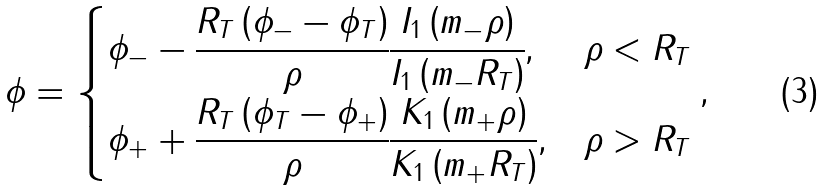Convert formula to latex. <formula><loc_0><loc_0><loc_500><loc_500>\phi = \begin{cases} \phi _ { - } - \cfrac { { R _ { T } \left ( { \phi _ { - } - \phi _ { T } } \right ) } } { \rho } \cfrac { { I _ { 1 } \left ( { m _ { - } \rho } \right ) } } { { I _ { 1 } \left ( { m _ { - } R _ { T } } \right ) } } , & \rho < R _ { T } \\ \phi _ { + } + \cfrac { { R _ { T } \left ( { \phi _ { T } - \phi _ { + } } \right ) } } { \rho } \cfrac { { K _ { 1 } \left ( { m _ { + } \rho } \right ) } } { { K _ { 1 } \left ( { m _ { + } R _ { T } } \right ) } } , & \rho > R _ { T } \\ \end{cases} ,</formula> 